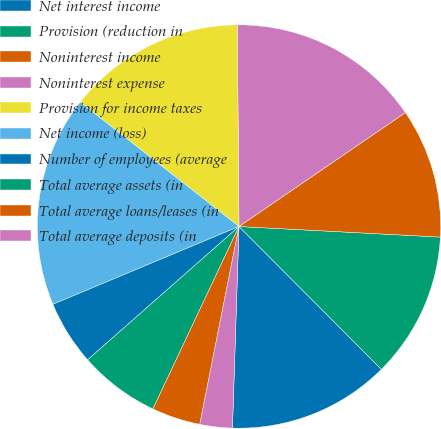Convert chart to OTSL. <chart><loc_0><loc_0><loc_500><loc_500><pie_chart><fcel>Net interest income<fcel>Provision (reduction in<fcel>Noninterest income<fcel>Noninterest expense<fcel>Provision for income taxes<fcel>Net income (loss)<fcel>Number of employees (average<fcel>Total average assets (in<fcel>Total average loans/leases (in<fcel>Total average deposits (in<nl><fcel>12.99%<fcel>11.69%<fcel>10.39%<fcel>15.58%<fcel>14.29%<fcel>16.88%<fcel>5.19%<fcel>6.49%<fcel>3.9%<fcel>2.6%<nl></chart> 